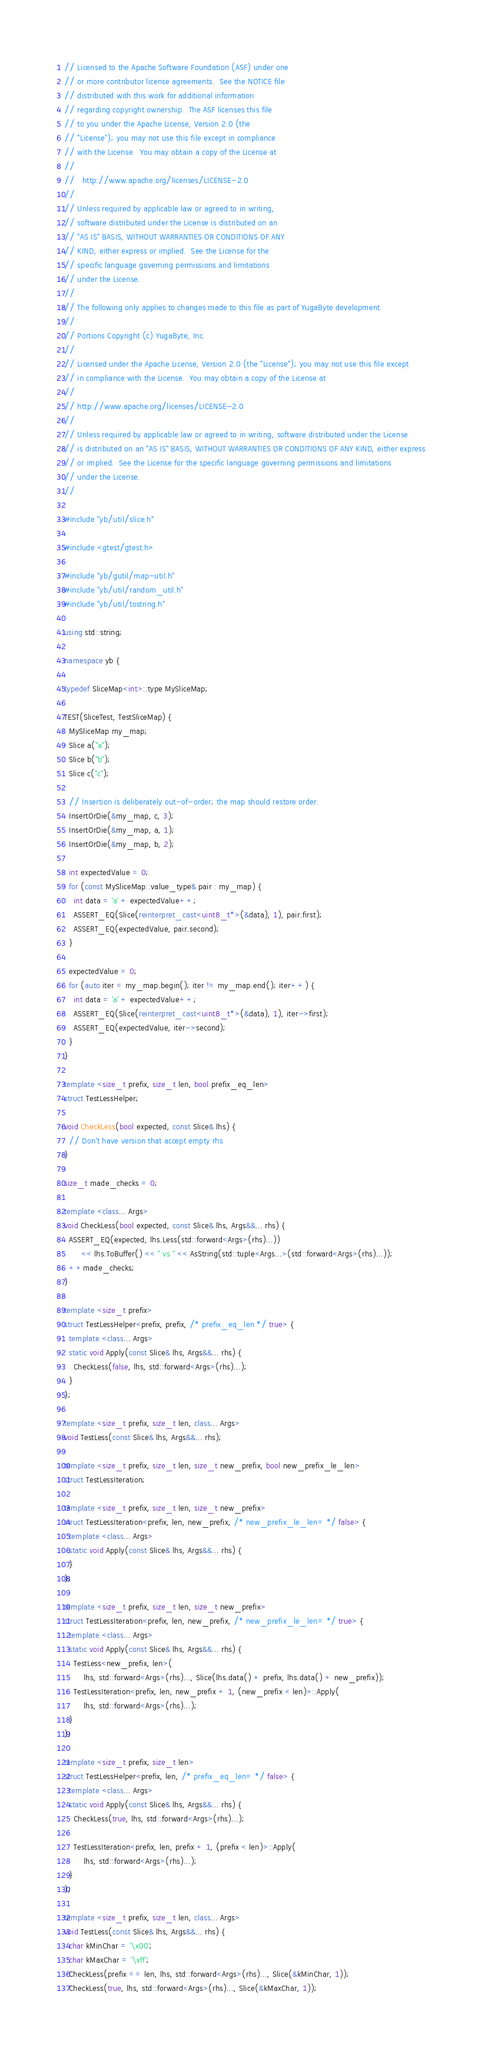<code> <loc_0><loc_0><loc_500><loc_500><_C++_>// Licensed to the Apache Software Foundation (ASF) under one
// or more contributor license agreements.  See the NOTICE file
// distributed with this work for additional information
// regarding copyright ownership.  The ASF licenses this file
// to you under the Apache License, Version 2.0 (the
// "License"); you may not use this file except in compliance
// with the License.  You may obtain a copy of the License at
//
//   http://www.apache.org/licenses/LICENSE-2.0
//
// Unless required by applicable law or agreed to in writing,
// software distributed under the License is distributed on an
// "AS IS" BASIS, WITHOUT WARRANTIES OR CONDITIONS OF ANY
// KIND, either express or implied.  See the License for the
// specific language governing permissions and limitations
// under the License.
//
// The following only applies to changes made to this file as part of YugaByte development.
//
// Portions Copyright (c) YugaByte, Inc.
//
// Licensed under the Apache License, Version 2.0 (the "License"); you may not use this file except
// in compliance with the License.  You may obtain a copy of the License at
//
// http://www.apache.org/licenses/LICENSE-2.0
//
// Unless required by applicable law or agreed to in writing, software distributed under the License
// is distributed on an "AS IS" BASIS, WITHOUT WARRANTIES OR CONDITIONS OF ANY KIND, either express
// or implied.  See the License for the specific language governing permissions and limitations
// under the License.
//

#include "yb/util/slice.h"

#include <gtest/gtest.h>

#include "yb/gutil/map-util.h"
#include "yb/util/random_util.h"
#include "yb/util/tostring.h"

using std::string;

namespace yb {

typedef SliceMap<int>::type MySliceMap;

TEST(SliceTest, TestSliceMap) {
  MySliceMap my_map;
  Slice a("a");
  Slice b("b");
  Slice c("c");

  // Insertion is deliberately out-of-order; the map should restore order.
  InsertOrDie(&my_map, c, 3);
  InsertOrDie(&my_map, a, 1);
  InsertOrDie(&my_map, b, 2);

  int expectedValue = 0;
  for (const MySliceMap::value_type& pair : my_map) {
    int data = 'a' + expectedValue++;
    ASSERT_EQ(Slice(reinterpret_cast<uint8_t*>(&data), 1), pair.first);
    ASSERT_EQ(expectedValue, pair.second);
  }

  expectedValue = 0;
  for (auto iter = my_map.begin(); iter != my_map.end(); iter++) {
    int data = 'a' + expectedValue++;
    ASSERT_EQ(Slice(reinterpret_cast<uint8_t*>(&data), 1), iter->first);
    ASSERT_EQ(expectedValue, iter->second);
  }
}

template <size_t prefix, size_t len, bool prefix_eq_len>
struct TestLessHelper;

void CheckLess(bool expected, const Slice& lhs) {
  // Don't have version that accept empty rhs
}

size_t made_checks = 0;

template <class... Args>
void CheckLess(bool expected, const Slice& lhs, Args&&... rhs) {
  ASSERT_EQ(expected, lhs.Less(std::forward<Args>(rhs)...))
       << lhs.ToBuffer() << " vs " << AsString(std::tuple<Args...>(std::forward<Args>(rhs)...));
  ++made_checks;
}

template <size_t prefix>
struct TestLessHelper<prefix, prefix, /* prefix_eq_len */ true> {
  template <class... Args>
  static void Apply(const Slice& lhs, Args&&... rhs) {
    CheckLess(false, lhs, std::forward<Args>(rhs)...);
  }
};

template <size_t prefix, size_t len, class... Args>
void TestLess(const Slice& lhs, Args&&... rhs);

template <size_t prefix, size_t len, size_t new_prefix, bool new_prefix_le_len>
struct TestLessIteration;

template <size_t prefix, size_t len, size_t new_prefix>
struct TestLessIteration<prefix, len, new_prefix, /* new_prefix_le_len= */ false> {
  template <class... Args>
  static void Apply(const Slice& lhs, Args&&... rhs) {
  }
};

template <size_t prefix, size_t len, size_t new_prefix>
struct TestLessIteration<prefix, len, new_prefix, /* new_prefix_le_len= */ true> {
  template <class... Args>
  static void Apply(const Slice& lhs, Args&&... rhs) {
    TestLess<new_prefix, len>(
        lhs, std::forward<Args>(rhs)..., Slice(lhs.data() + prefix, lhs.data() + new_prefix));
    TestLessIteration<prefix, len, new_prefix + 1, (new_prefix < len)>::Apply(
        lhs, std::forward<Args>(rhs)...);
  }
};

template <size_t prefix, size_t len>
struct TestLessHelper<prefix, len, /* prefix_eq_len= */ false> {
  template <class... Args>
  static void Apply(const Slice& lhs, Args&&... rhs) {
    CheckLess(true, lhs, std::forward<Args>(rhs)...);

    TestLessIteration<prefix, len, prefix + 1, (prefix < len)>::Apply(
        lhs, std::forward<Args>(rhs)...);
  }
};

template <size_t prefix, size_t len, class... Args>
void TestLess(const Slice& lhs, Args&&... rhs) {
  char kMinChar = '\x00';
  char kMaxChar = '\xff';
  CheckLess(prefix == len, lhs, std::forward<Args>(rhs)..., Slice(&kMinChar, 1));
  CheckLess(true, lhs, std::forward<Args>(rhs)..., Slice(&kMaxChar, 1));
</code> 